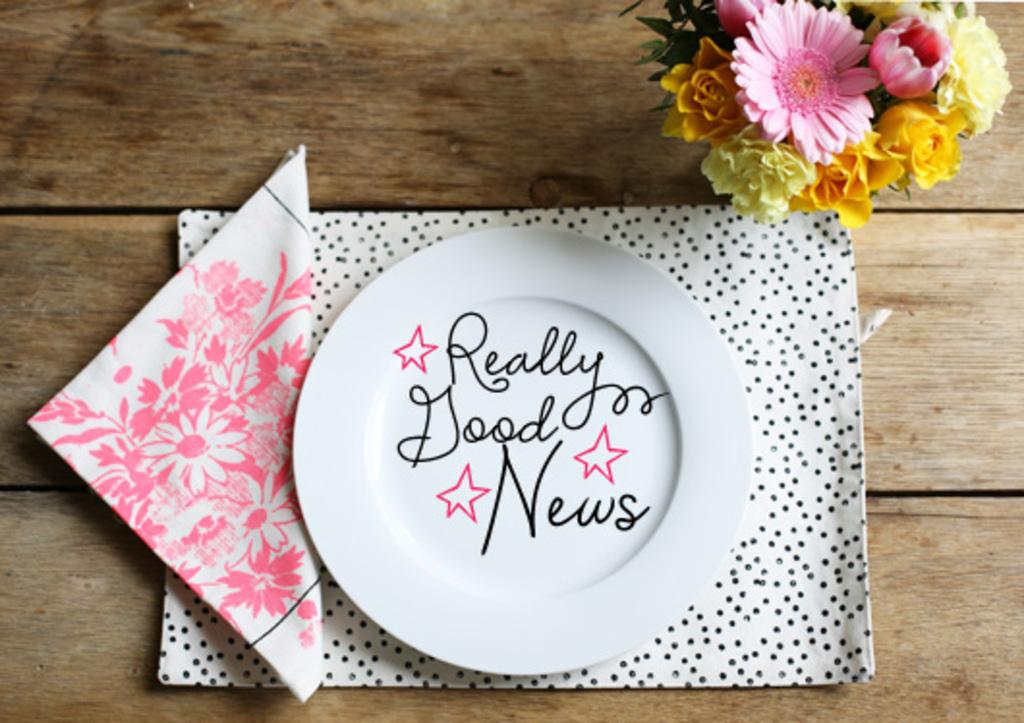<image>
Provide a brief description of the given image. Really Good News wording on a Clear White Plate that has flowers next to it. 